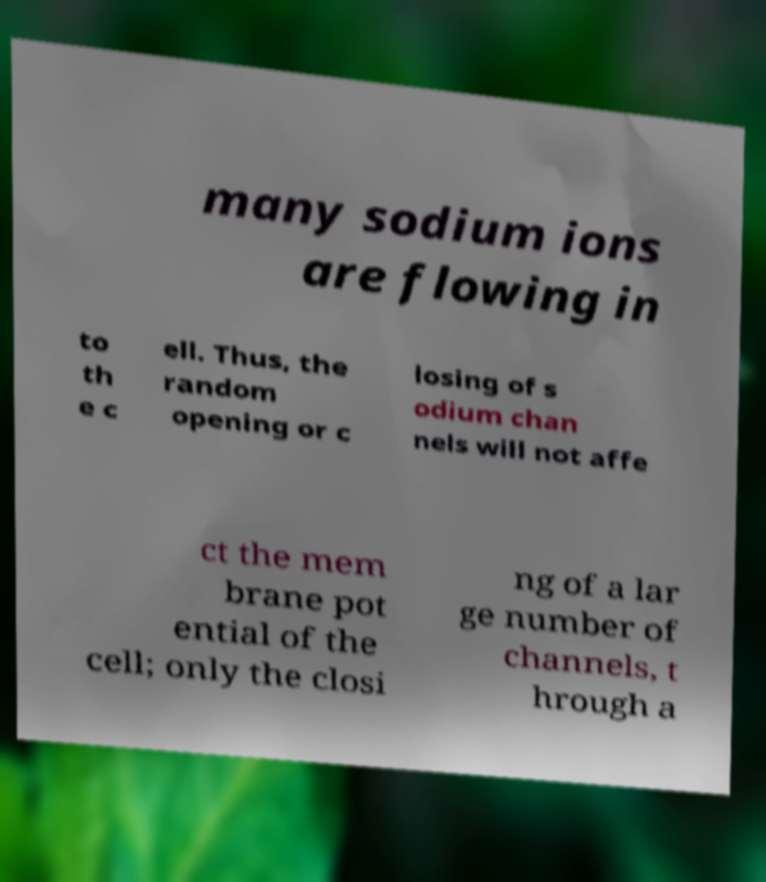For documentation purposes, I need the text within this image transcribed. Could you provide that? many sodium ions are flowing in to th e c ell. Thus, the random opening or c losing of s odium chan nels will not affe ct the mem brane pot ential of the cell; only the closi ng of a lar ge number of channels, t hrough a 